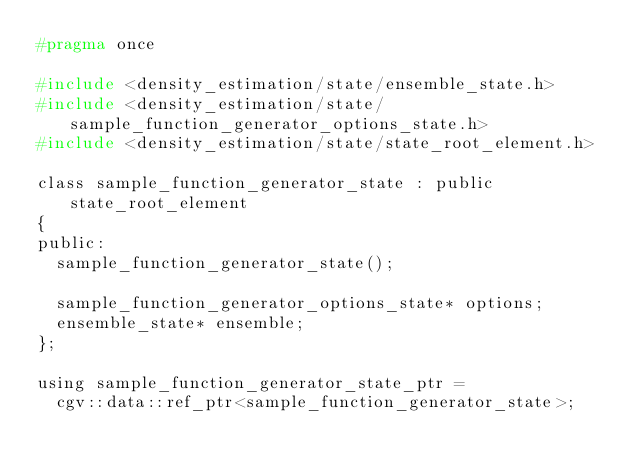<code> <loc_0><loc_0><loc_500><loc_500><_C_>#pragma once

#include <density_estimation/state/ensemble_state.h>
#include <density_estimation/state/sample_function_generator_options_state.h>
#include <density_estimation/state/state_root_element.h>

class sample_function_generator_state : public state_root_element
{
public:
  sample_function_generator_state();

  sample_function_generator_options_state* options;
  ensemble_state* ensemble;
};

using sample_function_generator_state_ptr =
  cgv::data::ref_ptr<sample_function_generator_state>;
</code> 